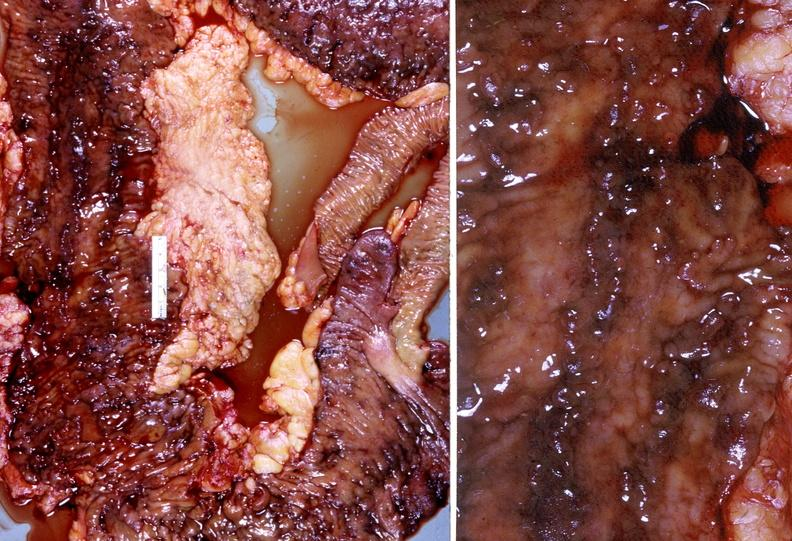what is present?
Answer the question using a single word or phrase. Gastrointestinal 